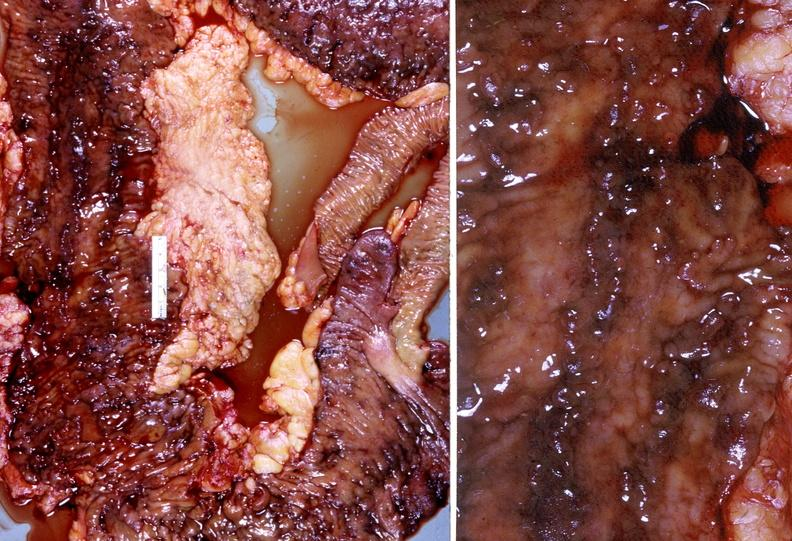what is present?
Answer the question using a single word or phrase. Gastrointestinal 